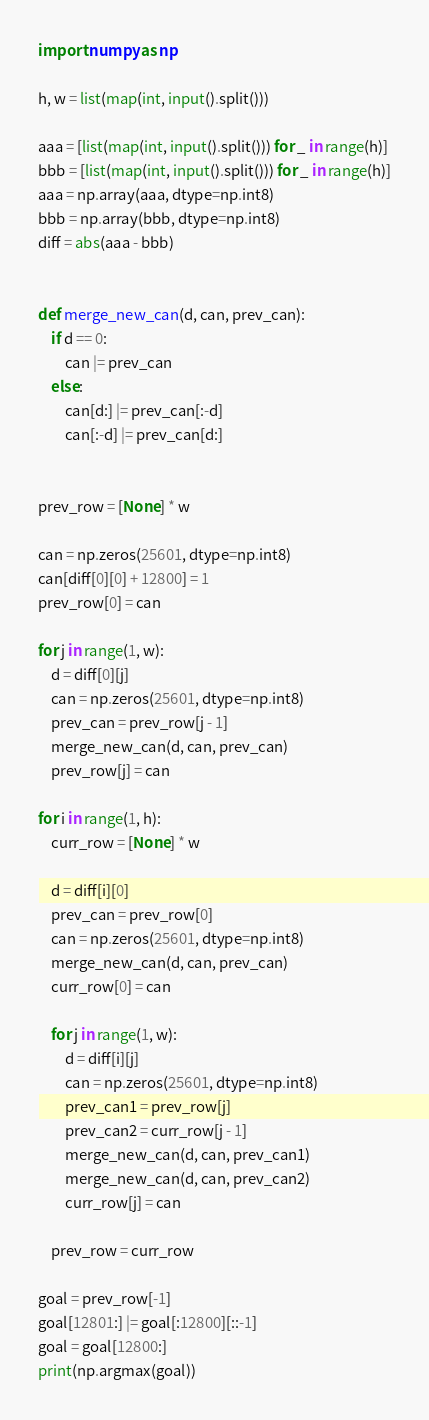<code> <loc_0><loc_0><loc_500><loc_500><_Python_>import numpy as np

h, w = list(map(int, input().split()))

aaa = [list(map(int, input().split())) for _ in range(h)]
bbb = [list(map(int, input().split())) for _ in range(h)]
aaa = np.array(aaa, dtype=np.int8)
bbb = np.array(bbb, dtype=np.int8)
diff = abs(aaa - bbb)


def merge_new_can(d, can, prev_can):
    if d == 0:
        can |= prev_can
    else:
        can[d:] |= prev_can[:-d]
        can[:-d] |= prev_can[d:]


prev_row = [None] * w

can = np.zeros(25601, dtype=np.int8)
can[diff[0][0] + 12800] = 1
prev_row[0] = can

for j in range(1, w):
    d = diff[0][j]
    can = np.zeros(25601, dtype=np.int8)
    prev_can = prev_row[j - 1]
    merge_new_can(d, can, prev_can)
    prev_row[j] = can

for i in range(1, h):
    curr_row = [None] * w

    d = diff[i][0]
    prev_can = prev_row[0]
    can = np.zeros(25601, dtype=np.int8)
    merge_new_can(d, can, prev_can)
    curr_row[0] = can

    for j in range(1, w):
        d = diff[i][j]
        can = np.zeros(25601, dtype=np.int8)
        prev_can1 = prev_row[j]
        prev_can2 = curr_row[j - 1]
        merge_new_can(d, can, prev_can1)
        merge_new_can(d, can, prev_can2)
        curr_row[j] = can

    prev_row = curr_row

goal = prev_row[-1]
goal[12801:] |= goal[:12800][::-1]
goal = goal[12800:]
print(np.argmax(goal))
</code> 